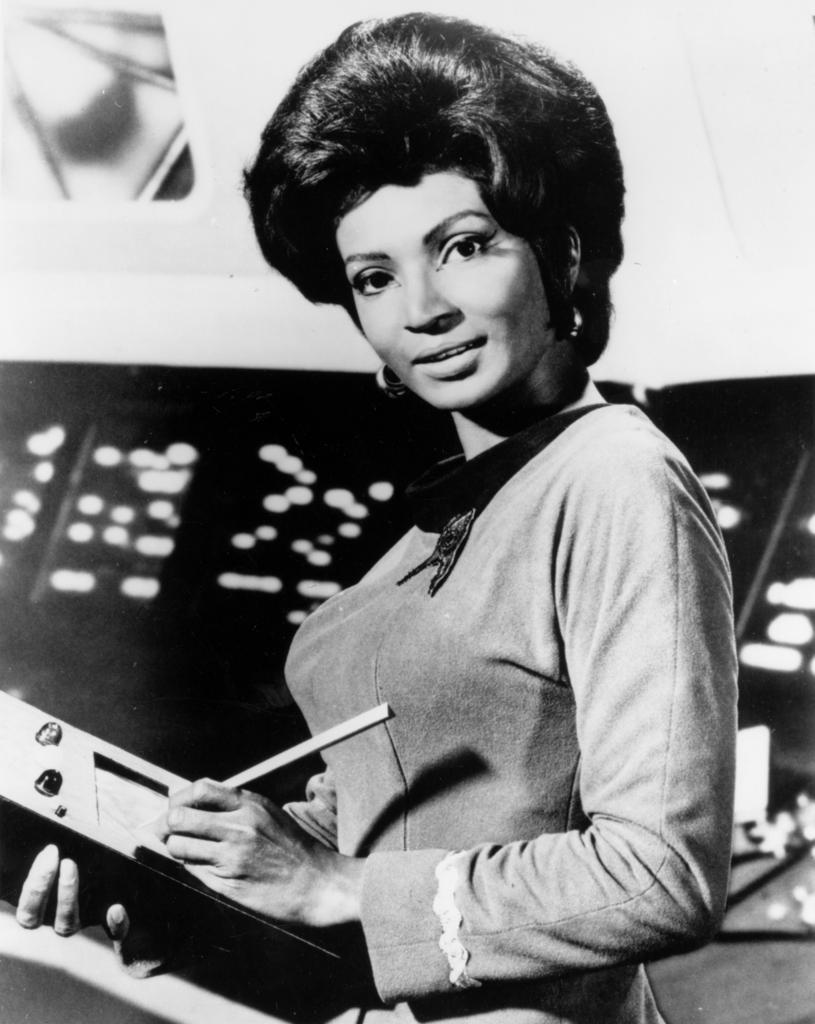Could you give a brief overview of what you see in this image? In this image we can see a lady holding a book, and writing something on it, at the background, we can see some other objects, and the picture is taken in a black and white mode. 